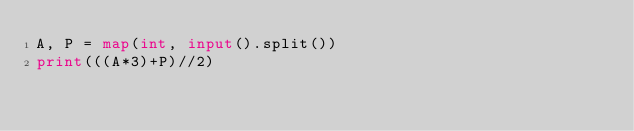Convert code to text. <code><loc_0><loc_0><loc_500><loc_500><_Python_>A, P = map(int, input().split())
print(((A*3)+P)//2)</code> 